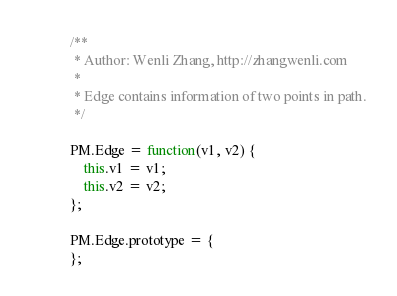Convert code to text. <code><loc_0><loc_0><loc_500><loc_500><_JavaScript_>/**
 * Author: Wenli Zhang, http://zhangwenli.com
 *
 * Edge contains information of two points in path.
 */

PM.Edge = function(v1, v2) {
    this.v1 = v1;
    this.v2 = v2;
};

PM.Edge.prototype = {
};
</code> 